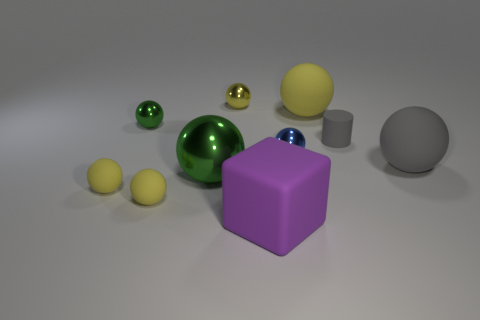How many large things are both on the right side of the matte cylinder and in front of the large green metallic ball? 0 